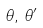Convert formula to latex. <formula><loc_0><loc_0><loc_500><loc_500>\theta , \, \theta ^ { \prime }</formula> 